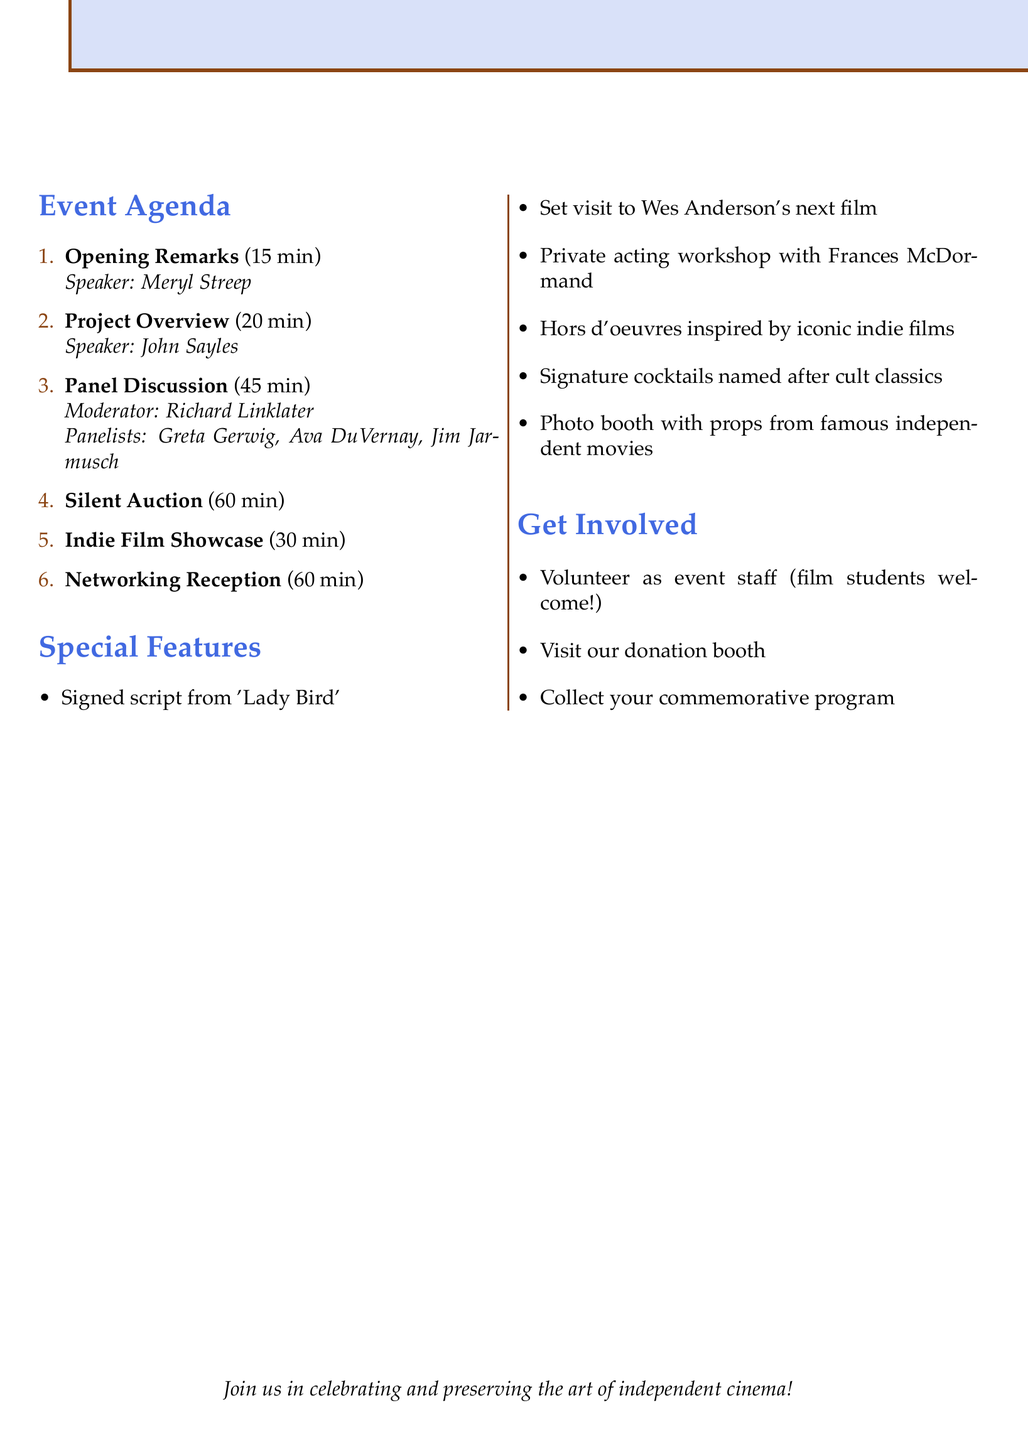What is the title of the event? The title of the event is stated at the beginning of the document.
Answer: Preserving Indie Cinema: A Fundraising Gala Who is the speaker for the Opening Remarks? The speaker for the Opening Remarks is mentioned in the corresponding section of the agenda.
Answer: Meryl Streep How long is the Panel Discussion scheduled for? The duration of the Panel Discussion is specified in the document.
Answer: 45 minutes What is the goal amount to raise from this fundraising event? The document explicitly mentions the goal amount right beneath the event title.
Answer: $100,000 Which renowned director is moderating the panel? The moderator for the panel is indicated in the document.
Answer: Richard Linklater Name one item in the Silent Auction. The Silent Auction items are listed clearly under that section of the agenda.
Answer: Signed script from 'Lady Bird' What will the Networking Reception feature? The activities for the Networking Reception are outlined in the agenda.
Answer: Hors d'oeuvres inspired by iconic indie films Which organization is suggested for collaboration on social media promotion? The document presents this collaboration idea under promotion ideas.
Answer: Sundance Institute What does the commemorative program feature? The special consideration section mentions specific content included in the program.
Answer: Essays by renowned indie filmmakers 